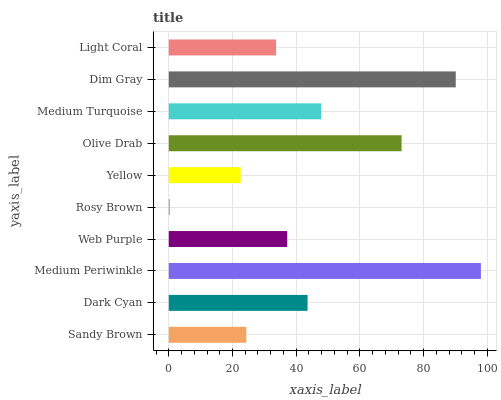Is Rosy Brown the minimum?
Answer yes or no. Yes. Is Medium Periwinkle the maximum?
Answer yes or no. Yes. Is Dark Cyan the minimum?
Answer yes or no. No. Is Dark Cyan the maximum?
Answer yes or no. No. Is Dark Cyan greater than Sandy Brown?
Answer yes or no. Yes. Is Sandy Brown less than Dark Cyan?
Answer yes or no. Yes. Is Sandy Brown greater than Dark Cyan?
Answer yes or no. No. Is Dark Cyan less than Sandy Brown?
Answer yes or no. No. Is Dark Cyan the high median?
Answer yes or no. Yes. Is Web Purple the low median?
Answer yes or no. Yes. Is Olive Drab the high median?
Answer yes or no. No. Is Olive Drab the low median?
Answer yes or no. No. 